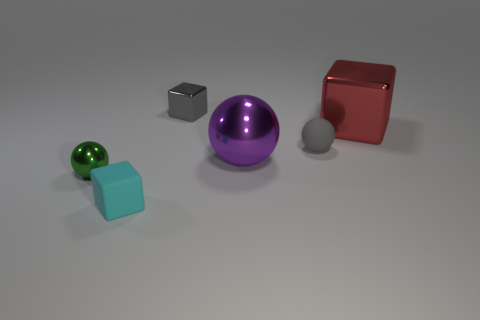Is the shape of the red object in front of the small gray block the same as the matte object behind the purple ball?
Your answer should be very brief. No. There is a metal thing behind the red block; how big is it?
Provide a succinct answer. Small. There is a thing that is to the left of the small cyan object that is in front of the red thing; how big is it?
Provide a succinct answer. Small. Is the number of tiny cyan cubes greater than the number of green shiny blocks?
Provide a succinct answer. Yes. Is the number of tiny metal blocks behind the green thing greater than the number of balls that are to the left of the tiny gray rubber thing?
Your answer should be very brief. No. There is a block that is both behind the tiny green sphere and on the left side of the large metal block; how big is it?
Provide a succinct answer. Small. How many gray balls have the same size as the gray metal cube?
Your answer should be very brief. 1. There is a ball that is the same color as the tiny metal block; what is its material?
Your answer should be very brief. Rubber. There is a purple object right of the small cyan matte thing; is it the same shape as the red object?
Make the answer very short. No. Is the number of tiny matte spheres behind the gray metallic cube less than the number of purple cylinders?
Make the answer very short. No. 